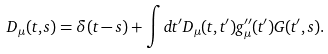<formula> <loc_0><loc_0><loc_500><loc_500>D _ { \mu } ( t , s ) = \delta ( t - s ) + \int d t ^ { \prime } D _ { \mu } ( t , t ^ { \prime } ) g ^ { \prime \prime } _ { \mu } ( t ^ { \prime } ) G ( t ^ { \prime } , s ) .</formula> 